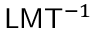<formula> <loc_0><loc_0><loc_500><loc_500>{ L } { M } { T } ^ { - 1 }</formula> 